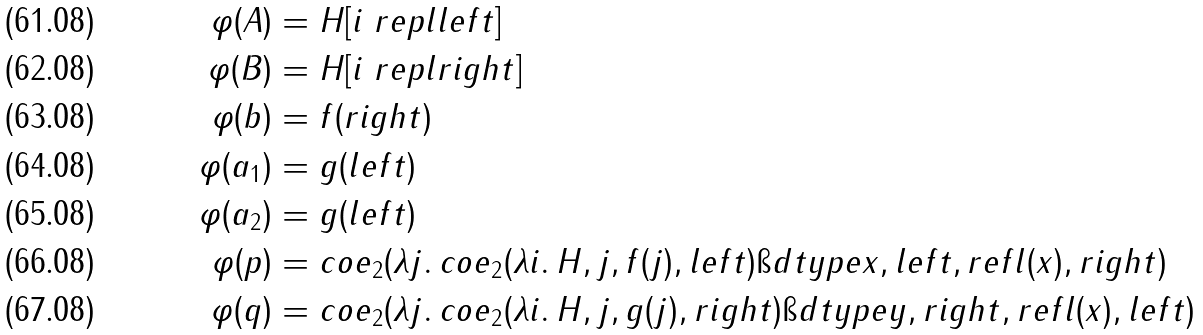<formula> <loc_0><loc_0><loc_500><loc_500>\varphi ( A ) & = H [ i \ r e p l l e f t ] \\ \varphi ( B ) & = H [ i \ r e p l r i g h t ] \\ \varphi ( b ) & = f ( r i g h t ) \\ \varphi ( a _ { 1 } ) & = g ( l e f t ) \\ \varphi ( a _ { 2 } ) & = g ( l e f t ) \\ \varphi ( p ) & = c o e _ { 2 } ( \lambda j . \, c o e _ { 2 } ( \lambda i . \, H , j , f ( j ) , l e f t ) \i d t y p e x , l e f t , r e f l ( x ) , r i g h t ) \\ \varphi ( q ) & = c o e _ { 2 } ( \lambda j . \, c o e _ { 2 } ( \lambda i . \, H , j , g ( j ) , r i g h t ) \i d t y p e y , r i g h t , r e f l ( x ) , l e f t )</formula> 